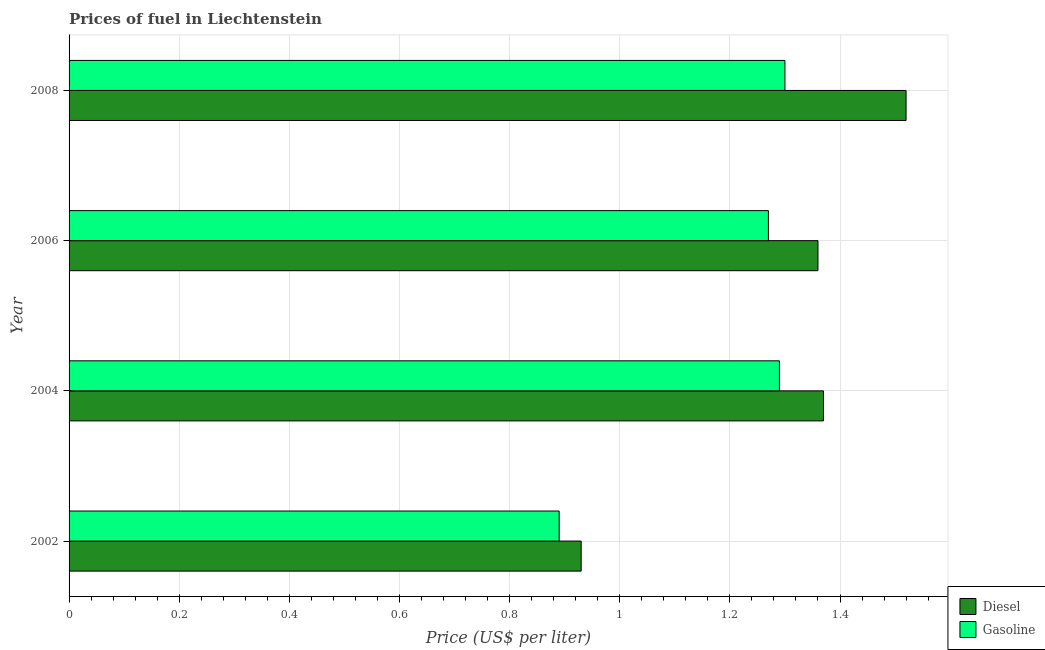How many groups of bars are there?
Your response must be concise. 4. Are the number of bars per tick equal to the number of legend labels?
Provide a succinct answer. Yes. How many bars are there on the 2nd tick from the bottom?
Offer a terse response. 2. What is the gasoline price in 2004?
Keep it short and to the point. 1.29. Across all years, what is the maximum diesel price?
Your answer should be compact. 1.52. Across all years, what is the minimum diesel price?
Offer a terse response. 0.93. In which year was the gasoline price minimum?
Your response must be concise. 2002. What is the total gasoline price in the graph?
Ensure brevity in your answer.  4.75. What is the difference between the gasoline price in 2004 and that in 2006?
Your response must be concise. 0.02. What is the difference between the gasoline price in 2002 and the diesel price in 2004?
Your response must be concise. -0.48. What is the average diesel price per year?
Your answer should be very brief. 1.29. In the year 2008, what is the difference between the diesel price and gasoline price?
Your response must be concise. 0.22. What is the difference between the highest and the second highest diesel price?
Provide a short and direct response. 0.15. What is the difference between the highest and the lowest gasoline price?
Keep it short and to the point. 0.41. In how many years, is the diesel price greater than the average diesel price taken over all years?
Keep it short and to the point. 3. Is the sum of the diesel price in 2002 and 2008 greater than the maximum gasoline price across all years?
Provide a short and direct response. Yes. What does the 1st bar from the top in 2006 represents?
Your answer should be very brief. Gasoline. What does the 1st bar from the bottom in 2004 represents?
Your answer should be very brief. Diesel. How many bars are there?
Make the answer very short. 8. Does the graph contain any zero values?
Your response must be concise. No. Does the graph contain grids?
Make the answer very short. Yes. Where does the legend appear in the graph?
Ensure brevity in your answer.  Bottom right. How many legend labels are there?
Give a very brief answer. 2. How are the legend labels stacked?
Give a very brief answer. Vertical. What is the title of the graph?
Ensure brevity in your answer.  Prices of fuel in Liechtenstein. What is the label or title of the X-axis?
Make the answer very short. Price (US$ per liter). What is the label or title of the Y-axis?
Ensure brevity in your answer.  Year. What is the Price (US$ per liter) in Diesel in 2002?
Make the answer very short. 0.93. What is the Price (US$ per liter) in Gasoline in 2002?
Give a very brief answer. 0.89. What is the Price (US$ per liter) of Diesel in 2004?
Give a very brief answer. 1.37. What is the Price (US$ per liter) of Gasoline in 2004?
Your answer should be very brief. 1.29. What is the Price (US$ per liter) of Diesel in 2006?
Keep it short and to the point. 1.36. What is the Price (US$ per liter) in Gasoline in 2006?
Keep it short and to the point. 1.27. What is the Price (US$ per liter) in Diesel in 2008?
Give a very brief answer. 1.52. What is the Price (US$ per liter) in Gasoline in 2008?
Provide a short and direct response. 1.3. Across all years, what is the maximum Price (US$ per liter) of Diesel?
Your answer should be compact. 1.52. Across all years, what is the minimum Price (US$ per liter) in Diesel?
Provide a succinct answer. 0.93. Across all years, what is the minimum Price (US$ per liter) in Gasoline?
Give a very brief answer. 0.89. What is the total Price (US$ per liter) of Diesel in the graph?
Offer a very short reply. 5.18. What is the total Price (US$ per liter) of Gasoline in the graph?
Make the answer very short. 4.75. What is the difference between the Price (US$ per liter) in Diesel in 2002 and that in 2004?
Your answer should be very brief. -0.44. What is the difference between the Price (US$ per liter) of Diesel in 2002 and that in 2006?
Make the answer very short. -0.43. What is the difference between the Price (US$ per liter) of Gasoline in 2002 and that in 2006?
Make the answer very short. -0.38. What is the difference between the Price (US$ per liter) of Diesel in 2002 and that in 2008?
Your response must be concise. -0.59. What is the difference between the Price (US$ per liter) in Gasoline in 2002 and that in 2008?
Your response must be concise. -0.41. What is the difference between the Price (US$ per liter) of Diesel in 2004 and that in 2006?
Offer a very short reply. 0.01. What is the difference between the Price (US$ per liter) in Gasoline in 2004 and that in 2006?
Your answer should be very brief. 0.02. What is the difference between the Price (US$ per liter) in Gasoline in 2004 and that in 2008?
Make the answer very short. -0.01. What is the difference between the Price (US$ per liter) in Diesel in 2006 and that in 2008?
Keep it short and to the point. -0.16. What is the difference between the Price (US$ per liter) of Gasoline in 2006 and that in 2008?
Your answer should be compact. -0.03. What is the difference between the Price (US$ per liter) of Diesel in 2002 and the Price (US$ per liter) of Gasoline in 2004?
Offer a very short reply. -0.36. What is the difference between the Price (US$ per liter) in Diesel in 2002 and the Price (US$ per liter) in Gasoline in 2006?
Offer a terse response. -0.34. What is the difference between the Price (US$ per liter) of Diesel in 2002 and the Price (US$ per liter) of Gasoline in 2008?
Provide a succinct answer. -0.37. What is the difference between the Price (US$ per liter) of Diesel in 2004 and the Price (US$ per liter) of Gasoline in 2008?
Give a very brief answer. 0.07. What is the difference between the Price (US$ per liter) in Diesel in 2006 and the Price (US$ per liter) in Gasoline in 2008?
Offer a very short reply. 0.06. What is the average Price (US$ per liter) in Diesel per year?
Your answer should be compact. 1.29. What is the average Price (US$ per liter) of Gasoline per year?
Make the answer very short. 1.19. In the year 2002, what is the difference between the Price (US$ per liter) of Diesel and Price (US$ per liter) of Gasoline?
Keep it short and to the point. 0.04. In the year 2006, what is the difference between the Price (US$ per liter) in Diesel and Price (US$ per liter) in Gasoline?
Your answer should be compact. 0.09. In the year 2008, what is the difference between the Price (US$ per liter) in Diesel and Price (US$ per liter) in Gasoline?
Make the answer very short. 0.22. What is the ratio of the Price (US$ per liter) in Diesel in 2002 to that in 2004?
Your answer should be very brief. 0.68. What is the ratio of the Price (US$ per liter) of Gasoline in 2002 to that in 2004?
Ensure brevity in your answer.  0.69. What is the ratio of the Price (US$ per liter) of Diesel in 2002 to that in 2006?
Provide a short and direct response. 0.68. What is the ratio of the Price (US$ per liter) of Gasoline in 2002 to that in 2006?
Provide a short and direct response. 0.7. What is the ratio of the Price (US$ per liter) in Diesel in 2002 to that in 2008?
Keep it short and to the point. 0.61. What is the ratio of the Price (US$ per liter) in Gasoline in 2002 to that in 2008?
Offer a terse response. 0.68. What is the ratio of the Price (US$ per liter) of Diesel in 2004 to that in 2006?
Your response must be concise. 1.01. What is the ratio of the Price (US$ per liter) of Gasoline in 2004 to that in 2006?
Provide a succinct answer. 1.02. What is the ratio of the Price (US$ per liter) in Diesel in 2004 to that in 2008?
Keep it short and to the point. 0.9. What is the ratio of the Price (US$ per liter) of Gasoline in 2004 to that in 2008?
Keep it short and to the point. 0.99. What is the ratio of the Price (US$ per liter) in Diesel in 2006 to that in 2008?
Ensure brevity in your answer.  0.89. What is the ratio of the Price (US$ per liter) of Gasoline in 2006 to that in 2008?
Make the answer very short. 0.98. What is the difference between the highest and the second highest Price (US$ per liter) of Diesel?
Offer a very short reply. 0.15. What is the difference between the highest and the lowest Price (US$ per liter) of Diesel?
Give a very brief answer. 0.59. What is the difference between the highest and the lowest Price (US$ per liter) of Gasoline?
Provide a short and direct response. 0.41. 